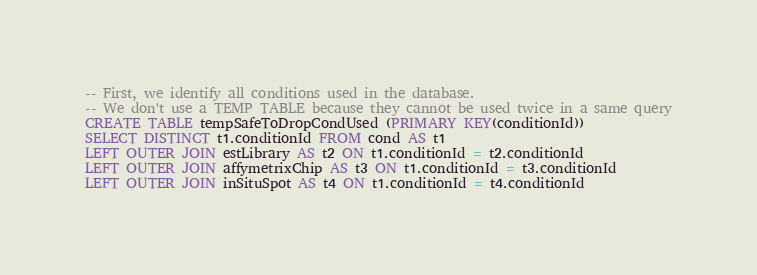<code> <loc_0><loc_0><loc_500><loc_500><_SQL_>-- First, we identify all conditions used in the database.
-- We don't use a TEMP TABLE because they cannot be used twice in a same query
CREATE TABLE tempSafeToDropCondUsed (PRIMARY KEY(conditionId))
SELECT DISTINCT t1.conditionId FROM cond AS t1
LEFT OUTER JOIN estLibrary AS t2 ON t1.conditionId = t2.conditionId
LEFT OUTER JOIN affymetrixChip AS t3 ON t1.conditionId = t3.conditionId
LEFT OUTER JOIN inSituSpot AS t4 ON t1.conditionId = t4.conditionId</code> 